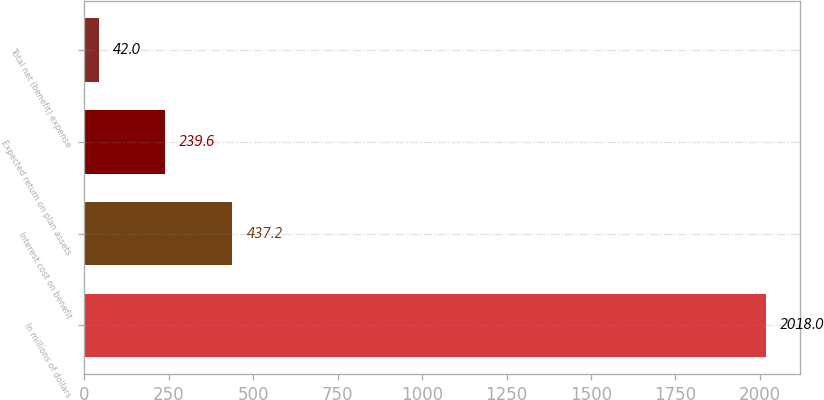<chart> <loc_0><loc_0><loc_500><loc_500><bar_chart><fcel>In millions of dollars<fcel>Interest cost on benefit<fcel>Expected return on plan assets<fcel>Total net (benefit) expense<nl><fcel>2018<fcel>437.2<fcel>239.6<fcel>42<nl></chart> 